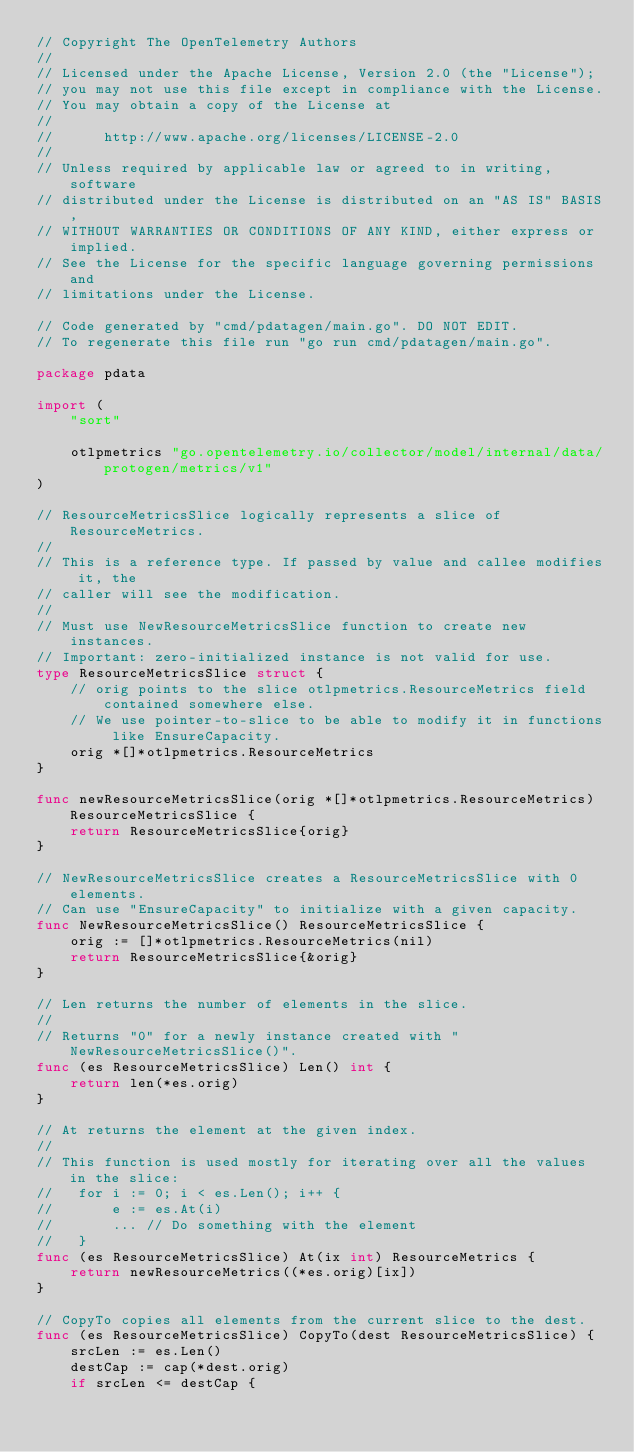<code> <loc_0><loc_0><loc_500><loc_500><_Go_>// Copyright The OpenTelemetry Authors
//
// Licensed under the Apache License, Version 2.0 (the "License");
// you may not use this file except in compliance with the License.
// You may obtain a copy of the License at
//
//      http://www.apache.org/licenses/LICENSE-2.0
//
// Unless required by applicable law or agreed to in writing, software
// distributed under the License is distributed on an "AS IS" BASIS,
// WITHOUT WARRANTIES OR CONDITIONS OF ANY KIND, either express or implied.
// See the License for the specific language governing permissions and
// limitations under the License.

// Code generated by "cmd/pdatagen/main.go". DO NOT EDIT.
// To regenerate this file run "go run cmd/pdatagen/main.go".

package pdata

import (
	"sort"

	otlpmetrics "go.opentelemetry.io/collector/model/internal/data/protogen/metrics/v1"
)

// ResourceMetricsSlice logically represents a slice of ResourceMetrics.
//
// This is a reference type. If passed by value and callee modifies it, the
// caller will see the modification.
//
// Must use NewResourceMetricsSlice function to create new instances.
// Important: zero-initialized instance is not valid for use.
type ResourceMetricsSlice struct {
	// orig points to the slice otlpmetrics.ResourceMetrics field contained somewhere else.
	// We use pointer-to-slice to be able to modify it in functions like EnsureCapacity.
	orig *[]*otlpmetrics.ResourceMetrics
}

func newResourceMetricsSlice(orig *[]*otlpmetrics.ResourceMetrics) ResourceMetricsSlice {
	return ResourceMetricsSlice{orig}
}

// NewResourceMetricsSlice creates a ResourceMetricsSlice with 0 elements.
// Can use "EnsureCapacity" to initialize with a given capacity.
func NewResourceMetricsSlice() ResourceMetricsSlice {
	orig := []*otlpmetrics.ResourceMetrics(nil)
	return ResourceMetricsSlice{&orig}
}

// Len returns the number of elements in the slice.
//
// Returns "0" for a newly instance created with "NewResourceMetricsSlice()".
func (es ResourceMetricsSlice) Len() int {
	return len(*es.orig)
}

// At returns the element at the given index.
//
// This function is used mostly for iterating over all the values in the slice:
//   for i := 0; i < es.Len(); i++ {
//       e := es.At(i)
//       ... // Do something with the element
//   }
func (es ResourceMetricsSlice) At(ix int) ResourceMetrics {
	return newResourceMetrics((*es.orig)[ix])
}

// CopyTo copies all elements from the current slice to the dest.
func (es ResourceMetricsSlice) CopyTo(dest ResourceMetricsSlice) {
	srcLen := es.Len()
	destCap := cap(*dest.orig)
	if srcLen <= destCap {</code> 